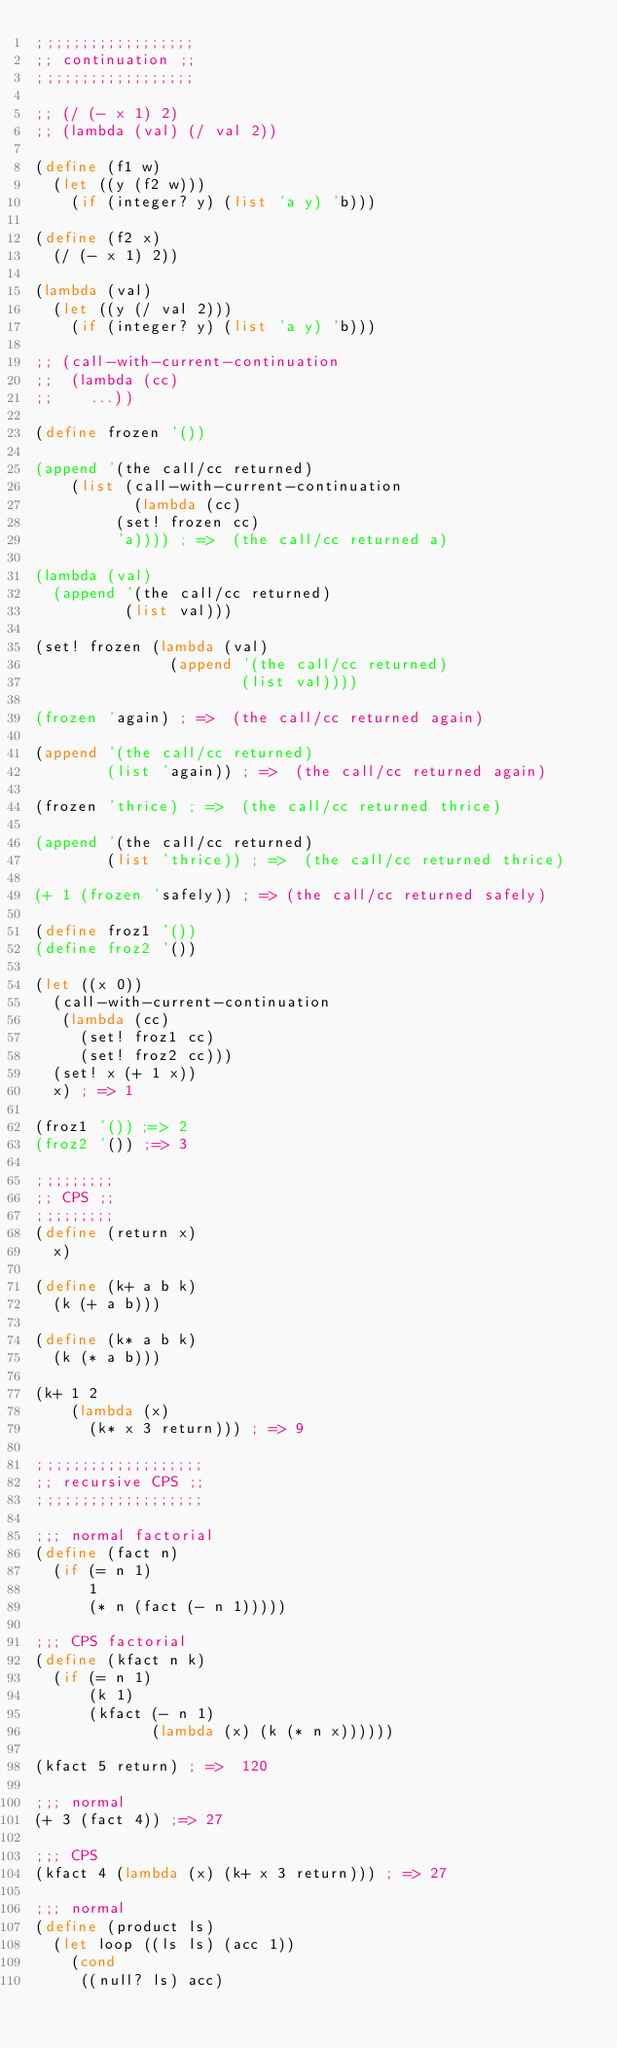<code> <loc_0><loc_0><loc_500><loc_500><_Scheme_>;;;;;;;;;;;;;;;;;;
;; continuation ;;
;;;;;;;;;;;;;;;;;;

;; (/ (- x 1) 2)
;; (lambda (val) (/ val 2))

(define (f1 w)
  (let ((y (f2 w)))
    (if (integer? y) (list 'a y) 'b)))

(define (f2 x)
  (/ (- x 1) 2))

(lambda (val)
  (let ((y (/ val 2)))
    (if (integer? y) (list 'a y) 'b)))

;; (call-with-current-continuation
;;  (lambda (cc)
;;    ...))

(define frozen '())

(append '(the call/cc returned)
	(list (call-with-current-continuation
	       (lambda (cc)
		 (set! frozen cc)
		 'a)))) ; =>  (the call/cc returned a)

(lambda (val)
  (append '(the call/cc returned)
          (list val)))

(set! frozen (lambda (val)
               (append '(the call/cc returned)
                       (list val))))

(frozen 'again) ; =>  (the call/cc returned again) 

(append '(the call/cc returned)
        (list 'again)) ; =>  (the call/cc returned again)

(frozen 'thrice) ; =>  (the call/cc returned thrice) 

(append '(the call/cc returned)
        (list 'thrice)) ; =>  (the call/cc returned thrice)

(+ 1 (frozen 'safely)) ; => (the call/cc returned safely)

(define froz1 '())
(define froz2 '())

(let ((x 0))
  (call-with-current-continuation
   (lambda (cc)
     (set! froz1 cc)
     (set! froz2 cc)))
  (set! x (+ 1 x))
  x) ; => 1

(froz1 '()) ;=> 2
(froz2 '()) ;=> 3

;;;;;;;;;
;; CPS ;;
;;;;;;;;;
(define (return x)
  x)

(define (k+ a b k)
  (k (+ a b)))

(define (k* a b k)
  (k (* a b)))

(k+ 1 2
    (lambda (x)
      (k* x 3 return))) ; => 9

;;;;;;;;;;;;;;;;;;;
;; recursive CPS ;;
;;;;;;;;;;;;;;;;;;;

;;; normal factorial
(define (fact n)
  (if (= n 1) 
      1
      (* n (fact (- n 1)))))

;;; CPS factorial
(define (kfact n k)
  (if (= n 1) 
      (k 1)
      (kfact (- n 1)
             (lambda (x) (k (* n x))))))

(kfact 5 return) ; =>  120

;;; normal
(+ 3 (fact 4)) ;=> 27

;;; CPS
(kfact 4 (lambda (x) (k+ x 3 return))) ; => 27

;;; normal
(define (product ls)
  (let loop ((ls ls) (acc 1))
    (cond
     ((null? ls) acc)</code> 